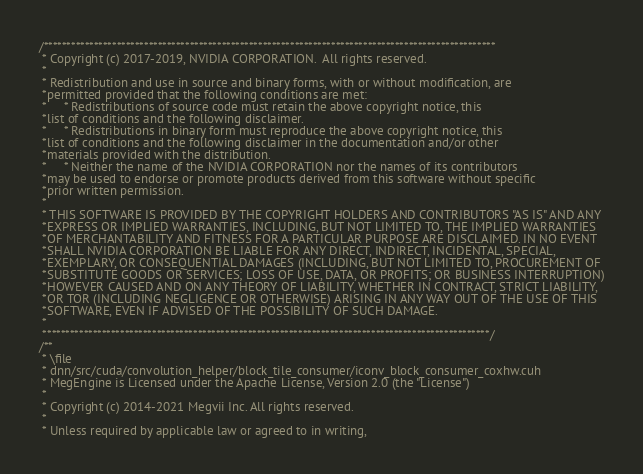<code> <loc_0><loc_0><loc_500><loc_500><_Cuda_>/***************************************************************************************************
 * Copyright (c) 2017-2019, NVIDIA CORPORATION.  All rights reserved.
 *
 * Redistribution and use in source and binary forms, with or without modification, are
 *permitted provided that the following conditions are met:
 *     * Redistributions of source code must retain the above copyright notice, this
 *list of conditions and the following disclaimer.
 *     * Redistributions in binary form must reproduce the above copyright notice, this
 *list of conditions and the following disclaimer in the documentation and/or other
 *materials provided with the distribution.
 *     * Neither the name of the NVIDIA CORPORATION nor the names of its contributors
 *may be used to endorse or promote products derived from this software without specific
 *prior written permission.
 *
 * THIS SOFTWARE IS PROVIDED BY THE COPYRIGHT HOLDERS AND CONTRIBUTORS "AS IS" AND ANY
 *EXPRESS OR IMPLIED WARRANTIES, INCLUDING, BUT NOT LIMITED TO, THE IMPLIED WARRANTIES
 *OF MERCHANTABILITY AND FITNESS FOR A PARTICULAR PURPOSE ARE DISCLAIMED. IN NO EVENT
 *SHALL NVIDIA CORPORATION BE LIABLE FOR ANY DIRECT, INDIRECT, INCIDENTAL, SPECIAL,
 *EXEMPLARY, OR CONSEQUENTIAL DAMAGES (INCLUDING, BUT NOT LIMITED TO, PROCUREMENT OF
 *SUBSTITUTE GOODS OR SERVICES; LOSS OF USE, DATA, OR PROFITS; OR BUSINESS INTERRUPTION)
 *HOWEVER CAUSED AND ON ANY THEORY OF LIABILITY, WHETHER IN CONTRACT, STRICT LIABILITY,
 *OR TOR (INCLUDING NEGLIGENCE OR OTHERWISE) ARISING IN ANY WAY OUT OF THE USE OF THIS
 *SOFTWARE, EVEN IF ADVISED OF THE POSSIBILITY OF SUCH DAMAGE.
 *
 **************************************************************************************************/
/**
 * \file
 * dnn/src/cuda/convolution_helper/block_tile_consumer/iconv_block_consumer_coxhw.cuh
 * MegEngine is Licensed under the Apache License, Version 2.0 (the "License")
 *
 * Copyright (c) 2014-2021 Megvii Inc. All rights reserved.
 *
 * Unless required by applicable law or agreed to in writing,</code> 